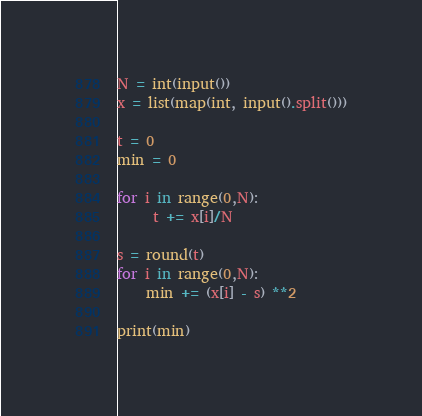<code> <loc_0><loc_0><loc_500><loc_500><_Python_>N = int(input())
x = list(map(int, input().split()))
 
t = 0
min = 0

for i in range(0,N):
     t += x[i]/N

s = round(t)
for i in range(0,N):
    min += (x[i] - s) **2

print(min)</code> 